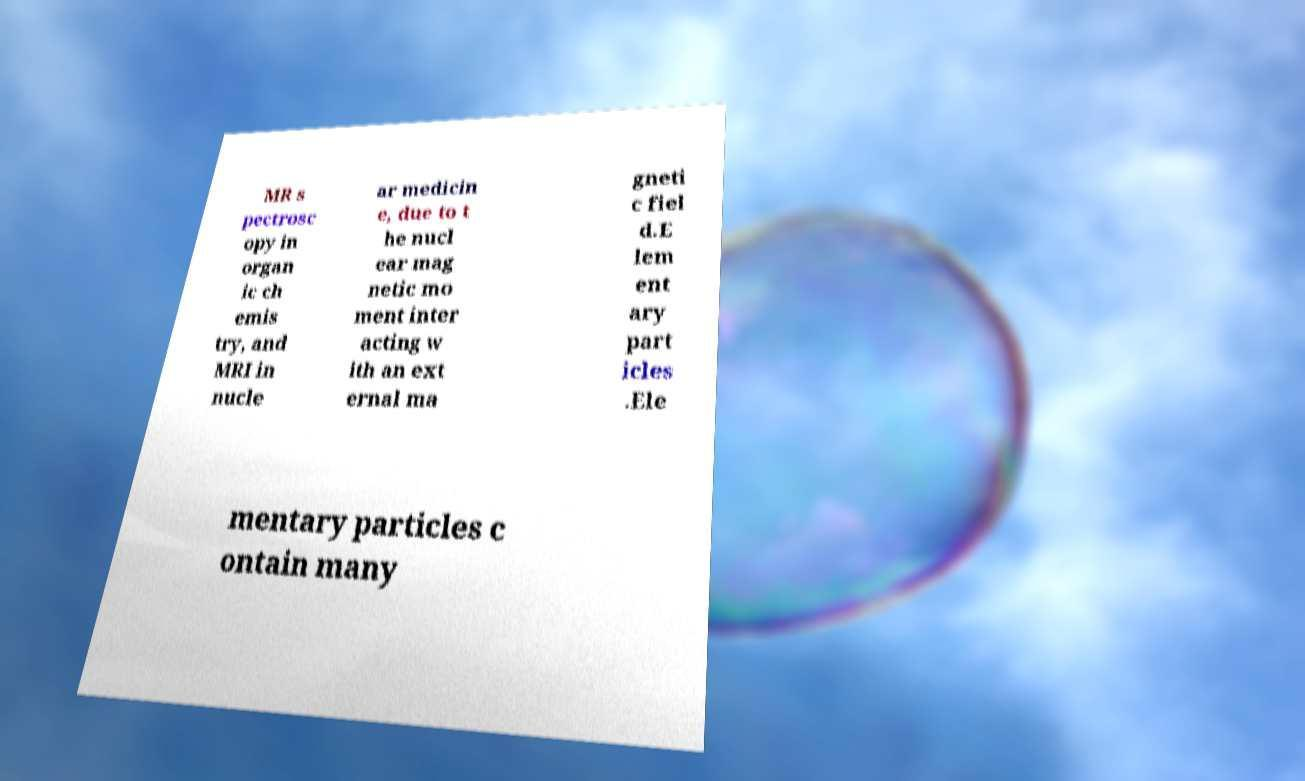Please read and relay the text visible in this image. What does it say? MR s pectrosc opy in organ ic ch emis try, and MRI in nucle ar medicin e, due to t he nucl ear mag netic mo ment inter acting w ith an ext ernal ma gneti c fiel d.E lem ent ary part icles .Ele mentary particles c ontain many 